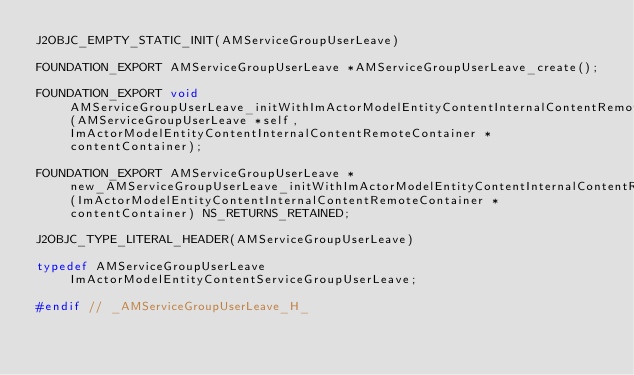Convert code to text. <code><loc_0><loc_0><loc_500><loc_500><_C_>J2OBJC_EMPTY_STATIC_INIT(AMServiceGroupUserLeave)

FOUNDATION_EXPORT AMServiceGroupUserLeave *AMServiceGroupUserLeave_create();

FOUNDATION_EXPORT void AMServiceGroupUserLeave_initWithImActorModelEntityContentInternalContentRemoteContainer_(AMServiceGroupUserLeave *self, ImActorModelEntityContentInternalContentRemoteContainer *contentContainer);

FOUNDATION_EXPORT AMServiceGroupUserLeave *new_AMServiceGroupUserLeave_initWithImActorModelEntityContentInternalContentRemoteContainer_(ImActorModelEntityContentInternalContentRemoteContainer *contentContainer) NS_RETURNS_RETAINED;

J2OBJC_TYPE_LITERAL_HEADER(AMServiceGroupUserLeave)

typedef AMServiceGroupUserLeave ImActorModelEntityContentServiceGroupUserLeave;

#endif // _AMServiceGroupUserLeave_H_
</code> 